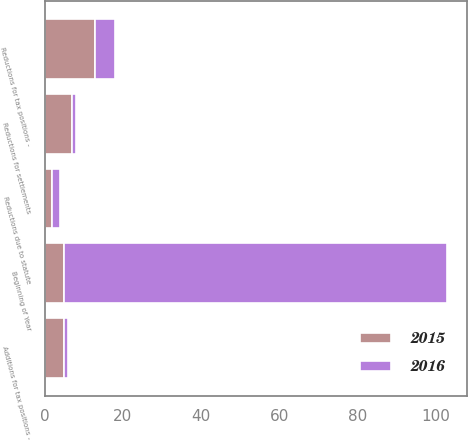Convert chart. <chart><loc_0><loc_0><loc_500><loc_500><stacked_bar_chart><ecel><fcel>Beginning of Year<fcel>Additions for tax positions -<fcel>Reductions for tax positions -<fcel>Reductions for settlements<fcel>Reductions due to statute<nl><fcel>2016<fcel>98<fcel>1<fcel>5<fcel>1<fcel>2<nl><fcel>2015<fcel>5<fcel>5<fcel>13<fcel>7<fcel>2<nl></chart> 